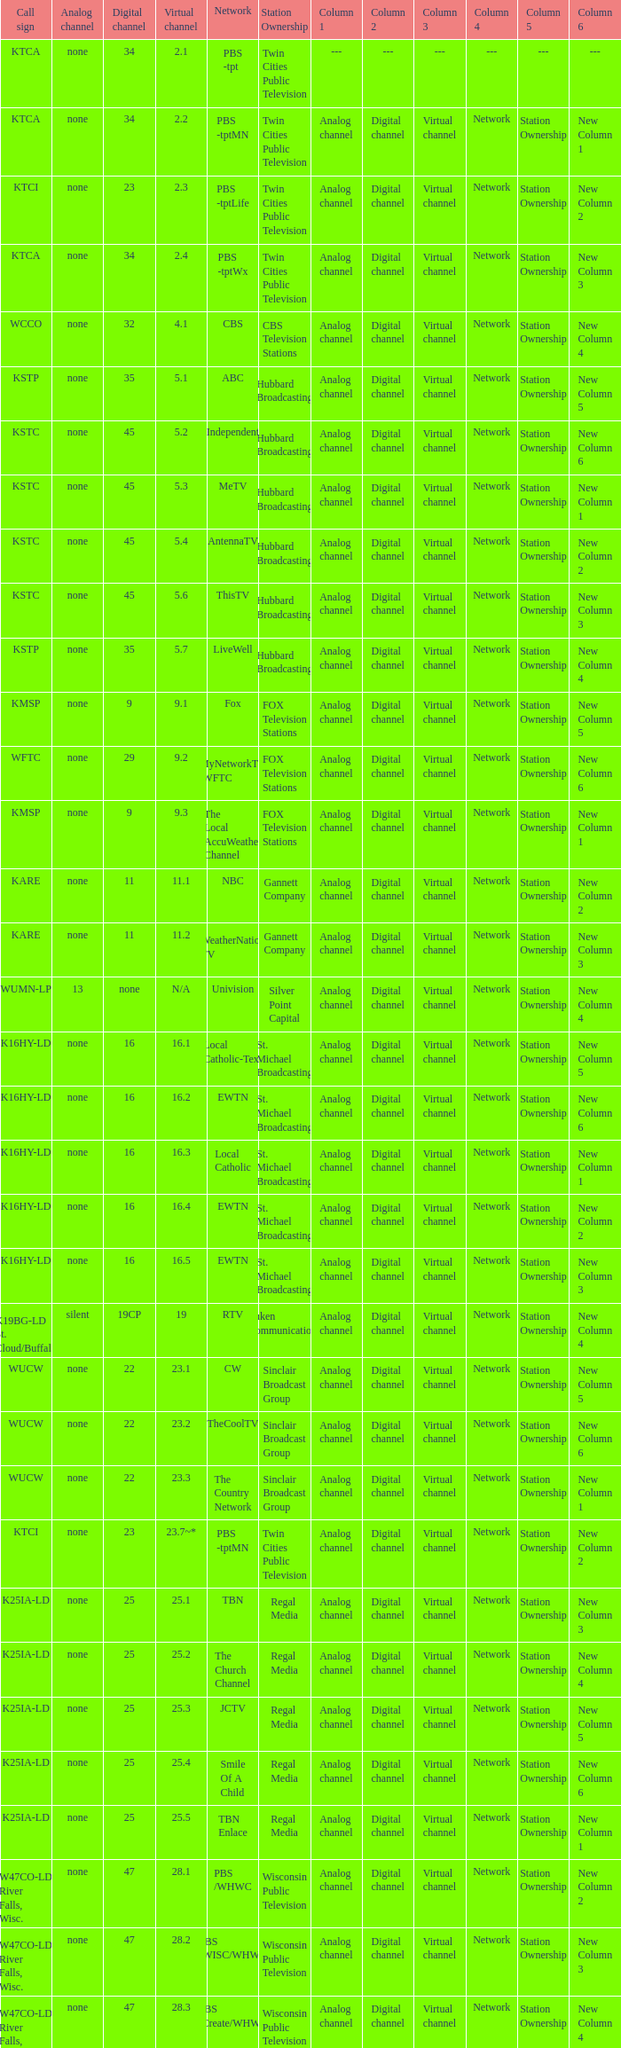Network of nbc is what digital channel? 11.0. Can you give me this table as a dict? {'header': ['Call sign', 'Analog channel', 'Digital channel', 'Virtual channel', 'Network', 'Station Ownership', 'Column 1', 'Column 2', 'Column 3', 'Column 4', 'Column 5', 'Column 6'], 'rows': [['KTCA', 'none', '34', '2.1', 'PBS -tpt', 'Twin Cities Public Television', '---', '---', '---', '---', '---', '---'], ['KTCA', 'none', '34', '2.2', 'PBS -tptMN', 'Twin Cities Public Television', 'Analog channel', 'Digital channel', 'Virtual channel', 'Network', 'Station Ownership', 'New Column 1'], ['KTCI', 'none', '23', '2.3', 'PBS -tptLife', 'Twin Cities Public Television', 'Analog channel', 'Digital channel', 'Virtual channel', 'Network', 'Station Ownership', 'New Column 2'], ['KTCA', 'none', '34', '2.4', 'PBS -tptWx', 'Twin Cities Public Television', 'Analog channel', 'Digital channel', 'Virtual channel', 'Network', 'Station Ownership', 'New Column 3'], ['WCCO', 'none', '32', '4.1', 'CBS', 'CBS Television Stations', 'Analog channel', 'Digital channel', 'Virtual channel', 'Network', 'Station Ownership', 'New Column 4'], ['KSTP', 'none', '35', '5.1', 'ABC', 'Hubbard Broadcasting', 'Analog channel', 'Digital channel', 'Virtual channel', 'Network', 'Station Ownership', 'New Column 5'], ['KSTC', 'none', '45', '5.2', 'Independent', 'Hubbard Broadcasting', 'Analog channel', 'Digital channel', 'Virtual channel', 'Network', 'Station Ownership', 'New Column 6'], ['KSTC', 'none', '45', '5.3', 'MeTV', 'Hubbard Broadcasting', 'Analog channel', 'Digital channel', 'Virtual channel', 'Network', 'Station Ownership', 'New Column 1'], ['KSTC', 'none', '45', '5.4', 'AntennaTV', 'Hubbard Broadcasting', 'Analog channel', 'Digital channel', 'Virtual channel', 'Network', 'Station Ownership', 'New Column 2'], ['KSTC', 'none', '45', '5.6', 'ThisTV', 'Hubbard Broadcasting', 'Analog channel', 'Digital channel', 'Virtual channel', 'Network', 'Station Ownership', 'New Column 3'], ['KSTP', 'none', '35', '5.7', 'LiveWell', 'Hubbard Broadcasting', 'Analog channel', 'Digital channel', 'Virtual channel', 'Network', 'Station Ownership', 'New Column 4'], ['KMSP', 'none', '9', '9.1', 'Fox', 'FOX Television Stations', 'Analog channel', 'Digital channel', 'Virtual channel', 'Network', 'Station Ownership', 'New Column 5'], ['WFTC', 'none', '29', '9.2', 'MyNetworkTV /WFTC', 'FOX Television Stations', 'Analog channel', 'Digital channel', 'Virtual channel', 'Network', 'Station Ownership', 'New Column 6'], ['KMSP', 'none', '9', '9.3', 'The Local AccuWeather Channel', 'FOX Television Stations', 'Analog channel', 'Digital channel', 'Virtual channel', 'Network', 'Station Ownership', 'New Column 1'], ['KARE', 'none', '11', '11.1', 'NBC', 'Gannett Company', 'Analog channel', 'Digital channel', 'Virtual channel', 'Network', 'Station Ownership', 'New Column 2'], ['KARE', 'none', '11', '11.2', 'WeatherNation TV', 'Gannett Company', 'Analog channel', 'Digital channel', 'Virtual channel', 'Network', 'Station Ownership', 'New Column 3'], ['WUMN-LP', '13', 'none', 'N/A', 'Univision', 'Silver Point Capital', 'Analog channel', 'Digital channel', 'Virtual channel', 'Network', 'Station Ownership', 'New Column 4'], ['K16HY-LD', 'none', '16', '16.1', 'Local Catholic-Text', 'St. Michael Broadcasting', 'Analog channel', 'Digital channel', 'Virtual channel', 'Network', 'Station Ownership', 'New Column 5'], ['K16HY-LD', 'none', '16', '16.2', 'EWTN', 'St. Michael Broadcasting', 'Analog channel', 'Digital channel', 'Virtual channel', 'Network', 'Station Ownership', 'New Column 6'], ['K16HY-LD', 'none', '16', '16.3', 'Local Catholic', 'St. Michael Broadcasting', 'Analog channel', 'Digital channel', 'Virtual channel', 'Network', 'Station Ownership', 'New Column 1'], ['K16HY-LD', 'none', '16', '16.4', 'EWTN', 'St. Michael Broadcasting', 'Analog channel', 'Digital channel', 'Virtual channel', 'Network', 'Station Ownership', 'New Column 2'], ['K16HY-LD', 'none', '16', '16.5', 'EWTN', 'St. Michael Broadcasting', 'Analog channel', 'Digital channel', 'Virtual channel', 'Network', 'Station Ownership', 'New Column 3'], ['K19BG-LD St. Cloud/Buffalo', 'silent', '19CP', '19', 'RTV', 'Luken Communications', 'Analog channel', 'Digital channel', 'Virtual channel', 'Network', 'Station Ownership', 'New Column 4'], ['WUCW', 'none', '22', '23.1', 'CW', 'Sinclair Broadcast Group', 'Analog channel', 'Digital channel', 'Virtual channel', 'Network', 'Station Ownership', 'New Column 5'], ['WUCW', 'none', '22', '23.2', 'TheCoolTV', 'Sinclair Broadcast Group', 'Analog channel', 'Digital channel', 'Virtual channel', 'Network', 'Station Ownership', 'New Column 6'], ['WUCW', 'none', '22', '23.3', 'The Country Network', 'Sinclair Broadcast Group', 'Analog channel', 'Digital channel', 'Virtual channel', 'Network', 'Station Ownership', 'New Column 1'], ['KTCI', 'none', '23', '23.7~*', 'PBS -tptMN', 'Twin Cities Public Television', 'Analog channel', 'Digital channel', 'Virtual channel', 'Network', 'Station Ownership', 'New Column 2'], ['K25IA-LD', 'none', '25', '25.1', 'TBN', 'Regal Media', 'Analog channel', 'Digital channel', 'Virtual channel', 'Network', 'Station Ownership', 'New Column 3'], ['K25IA-LD', 'none', '25', '25.2', 'The Church Channel', 'Regal Media', 'Analog channel', 'Digital channel', 'Virtual channel', 'Network', 'Station Ownership', 'New Column 4'], ['K25IA-LD', 'none', '25', '25.3', 'JCTV', 'Regal Media', 'Analog channel', 'Digital channel', 'Virtual channel', 'Network', 'Station Ownership', 'New Column 5'], ['K25IA-LD', 'none', '25', '25.4', 'Smile Of A Child', 'Regal Media', 'Analog channel', 'Digital channel', 'Virtual channel', 'Network', 'Station Ownership', 'New Column 6'], ['K25IA-LD', 'none', '25', '25.5', 'TBN Enlace', 'Regal Media', 'Analog channel', 'Digital channel', 'Virtual channel', 'Network', 'Station Ownership', 'New Column 1'], ['W47CO-LD River Falls, Wisc.', 'none', '47', '28.1', 'PBS /WHWC', 'Wisconsin Public Television', 'Analog channel', 'Digital channel', 'Virtual channel', 'Network', 'Station Ownership', 'New Column 2'], ['W47CO-LD River Falls, Wisc.', 'none', '47', '28.2', 'PBS -WISC/WHWC', 'Wisconsin Public Television', 'Analog channel', 'Digital channel', 'Virtual channel', 'Network', 'Station Ownership', 'New Column 3'], ['W47CO-LD River Falls, Wisc.', 'none', '47', '28.3', 'PBS -Create/WHWC', 'Wisconsin Public Television', 'Analog channel', 'Digital channel', 'Virtual channel', 'Network', 'Station Ownership', 'New Column 4'], ['WFTC', 'none', '29', '29.1', 'MyNetworkTV', 'FOX Television Stations', 'Analog channel', 'Digital channel', 'Virtual channel', 'Network', 'Station Ownership', 'New Column 5'], ['KMSP', 'none', '9', '29.2', 'MyNetworkTV /WFTC', 'FOX Television Stations', 'Analog channel', 'Digital channel', 'Virtual channel', 'Network', 'Station Ownership', 'New Column 6'], ['WFTC', 'none', '29', '29.3', 'Bounce TV', 'FOX Television Stations', 'Analog channel', 'Digital channel', 'Virtual channel', 'Network', 'Station Ownership', 'New Column 1'], ['WFTC', 'none', '29', '29.4', 'Movies!', 'FOX Television Stations', 'Analog channel', 'Digital channel', 'Virtual channel', 'Network', 'Station Ownership', 'New Column 2'], ['K33LN-LD', 'none', '33', '33.1', '3ABN', 'Three Angels Broadcasting Network', 'Analog channel', 'Digital channel', 'Virtual channel', 'Network', 'Station Ownership', 'New Column 3'], ['K33LN-LD', 'none', '33', '33.2', '3ABN Proclaim!', 'Three Angels Broadcasting Network', 'Analog channel', 'Digital channel', 'Virtual channel', 'Network', 'Station Ownership', 'New Column 4'], ['K33LN-LD', 'none', '33', '33.3', '3ABN Dare to Dream', 'Three Angels Broadcasting Network', 'Analog channel', 'Digital channel', 'Virtual channel', 'Network', 'Station Ownership', 'New Column 5'], ['K33LN-LD', 'none', '33', '33.4', '3ABN Latino', 'Three Angels Broadcasting Network', 'Analog channel', 'Digital channel', 'Virtual channel', 'Network', 'Station Ownership', 'New Column 6'], ['K33LN-LD', 'none', '33', '33.5', '3ABN Radio-Audio', 'Three Angels Broadcasting Network', 'Analog channel', 'Digital channel', 'Virtual channel', 'Network', 'Station Ownership', 'New Column 1'], ['K33LN-LD', 'none', '33', '33.6', '3ABN Radio Latino-Audio', 'Three Angels Broadcasting Network', 'Analog channel', 'Digital channel', 'Virtual channel', 'Network', 'Station Ownership', 'New Column 2'], ['K33LN-LD', 'none', '33', '33.7', 'Radio 74-Audio', 'Three Angels Broadcasting Network', 'Analog channel', 'Digital channel', 'Virtual channel', 'Network', 'Station Ownership', 'New Column 3'], ['KPXM-TV', 'none', '40', '41.1', 'Ion Television', 'Ion Media Networks', 'Analog channel', 'Digital channel', 'Virtual channel', 'Network', 'Station Ownership', 'New Column 4'], ['KPXM-TV', 'none', '40', '41.2', 'Qubo Kids', 'Ion Media Networks', 'Analog channel', 'Digital channel', 'Virtual channel', 'Network', 'Station Ownership', 'New Column 5'], ['KPXM-TV', 'none', '40', '41.3', 'Ion Life', 'Ion Media Networks', 'Analog channel', 'Digital channel', 'Virtual channel', 'Network', 'Station Ownership', 'New Column 6'], ['K43HB-LD', 'none', '43', '43.1', 'HSN', 'Ventana Television', 'Analog channel', 'Digital channel', 'Virtual channel', 'Network', 'Station Ownership', 'New Column 1'], ['KHVM-LD', 'none', '48', '48.1', 'GCN - Religious', 'EICB TV', 'Analog channel', 'Digital channel', 'Virtual channel', 'Network', 'Station Ownership', 'New Column 2'], ['KTCJ-LD', 'none', '50', '50.1', 'CTVN - Religious', 'EICB TV', 'Analog channel', 'Digital channel', 'Virtual channel', 'Network', 'Station Ownership', 'New Column 3'], ['WDMI-LD', 'none', '31', '62.1', 'Daystar', 'Word of God Fellowship', 'Analog channel', 'Digital channel', 'Virtual channel', 'Network', 'Station Ownership', 'New Column 4']]} 